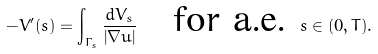Convert formula to latex. <formula><loc_0><loc_0><loc_500><loc_500>- V ^ { \prime } ( s ) = \int _ { \Gamma _ { s } } \frac { d V _ { s } } { \left | \nabla u \right | } \quad \text {for a.e.} \ s \in ( 0 , T ) .</formula> 